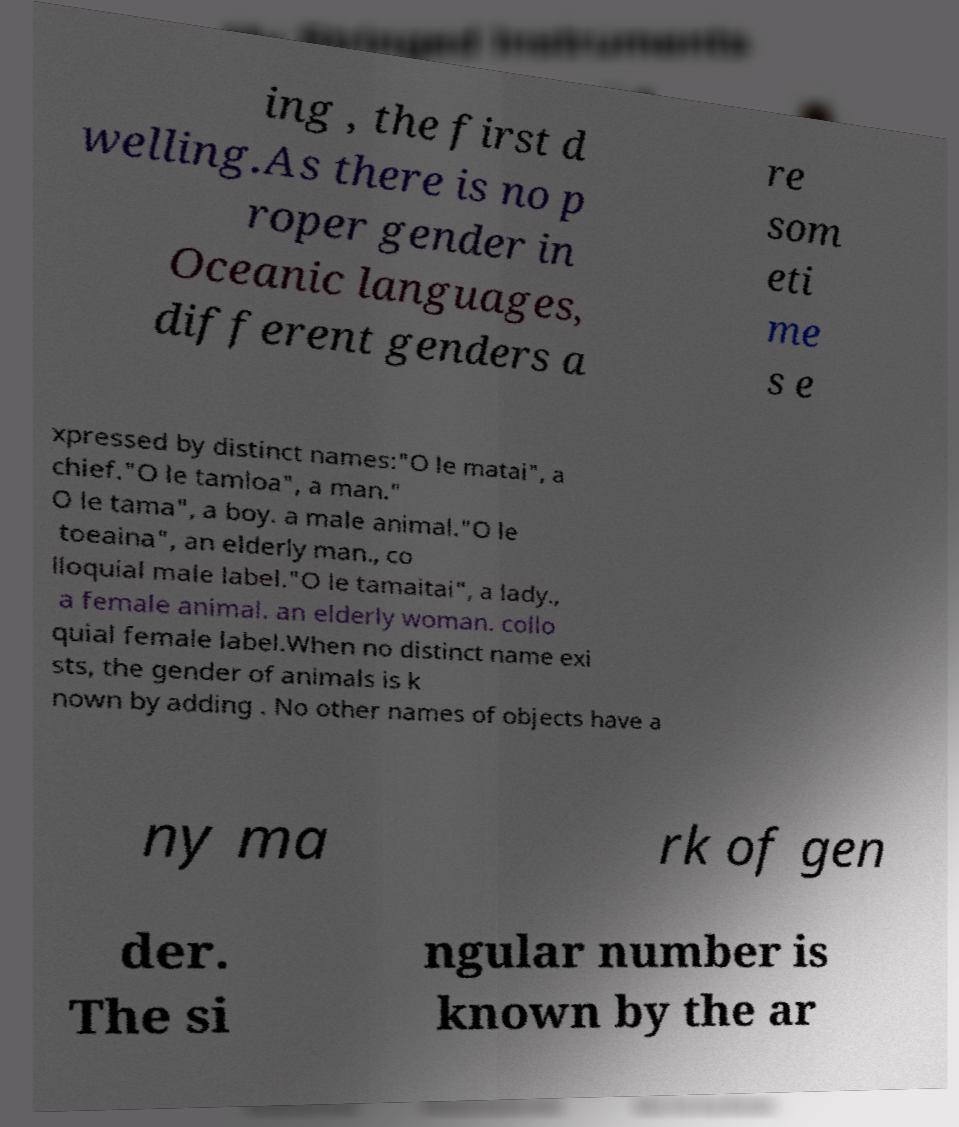Please identify and transcribe the text found in this image. ing , the first d welling.As there is no p roper gender in Oceanic languages, different genders a re som eti me s e xpressed by distinct names:"O le matai", a chief."O le tamloa", a man." O le tama", a boy. a male animal."O le toeaina", an elderly man., co lloquial male label."O le tamaitai", a lady., a female animal. an elderly woman. collo quial female label.When no distinct name exi sts, the gender of animals is k nown by adding . No other names of objects have a ny ma rk of gen der. The si ngular number is known by the ar 